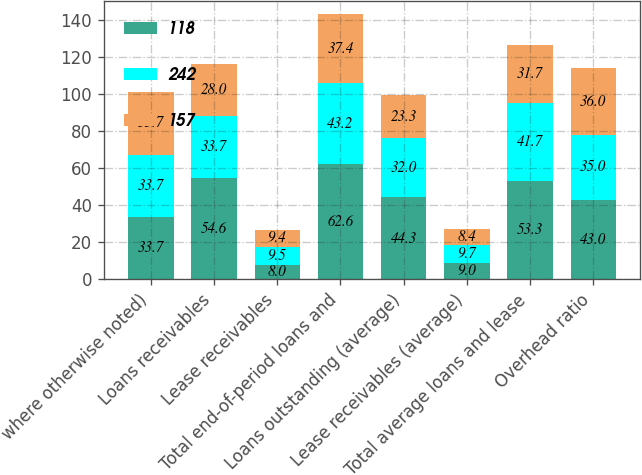Convert chart to OTSL. <chart><loc_0><loc_0><loc_500><loc_500><stacked_bar_chart><ecel><fcel>where otherwise noted)<fcel>Loans receivables<fcel>Lease receivables<fcel>Total end-of-period loans and<fcel>Loans outstanding (average)<fcel>Lease receivables (average)<fcel>Total average loans and lease<fcel>Overhead ratio<nl><fcel>118<fcel>33.7<fcel>54.6<fcel>8<fcel>62.6<fcel>44.3<fcel>9<fcel>53.3<fcel>43<nl><fcel>242<fcel>33.7<fcel>33.7<fcel>9.5<fcel>43.2<fcel>32<fcel>9.7<fcel>41.7<fcel>35<nl><fcel>157<fcel>33.7<fcel>28<fcel>9.4<fcel>37.4<fcel>23.3<fcel>8.4<fcel>31.7<fcel>36<nl></chart> 